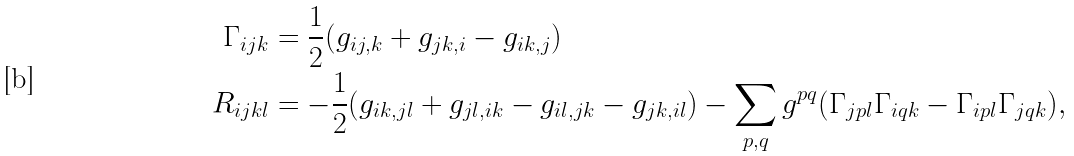Convert formula to latex. <formula><loc_0><loc_0><loc_500><loc_500>\Gamma _ { i j k } & = \frac { 1 } { 2 } ( g _ { i j , k } + g _ { j k , i } - g _ { i k , j } ) \\ R _ { i j k l } & = - \frac { 1 } { 2 } ( g _ { i k , j l } + g _ { j l , i k } - g _ { i l , j k } - g _ { j k , i l } ) - \sum _ { p , q } g ^ { p q } ( \Gamma _ { j p l } \Gamma _ { i q k } - \Gamma _ { i p l } \Gamma _ { j q k } ) ,</formula> 